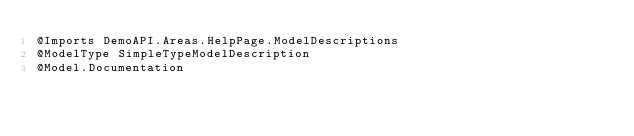<code> <loc_0><loc_0><loc_500><loc_500><_VisualBasic_>@Imports DemoAPI.Areas.HelpPage.ModelDescriptions
@ModelType SimpleTypeModelDescription
@Model.Documentation</code> 